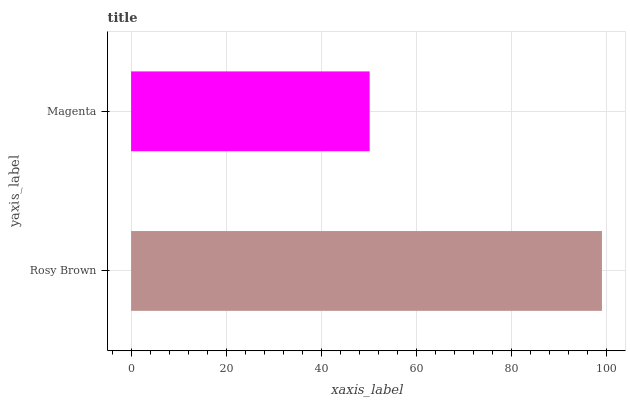Is Magenta the minimum?
Answer yes or no. Yes. Is Rosy Brown the maximum?
Answer yes or no. Yes. Is Magenta the maximum?
Answer yes or no. No. Is Rosy Brown greater than Magenta?
Answer yes or no. Yes. Is Magenta less than Rosy Brown?
Answer yes or no. Yes. Is Magenta greater than Rosy Brown?
Answer yes or no. No. Is Rosy Brown less than Magenta?
Answer yes or no. No. Is Rosy Brown the high median?
Answer yes or no. Yes. Is Magenta the low median?
Answer yes or no. Yes. Is Magenta the high median?
Answer yes or no. No. Is Rosy Brown the low median?
Answer yes or no. No. 